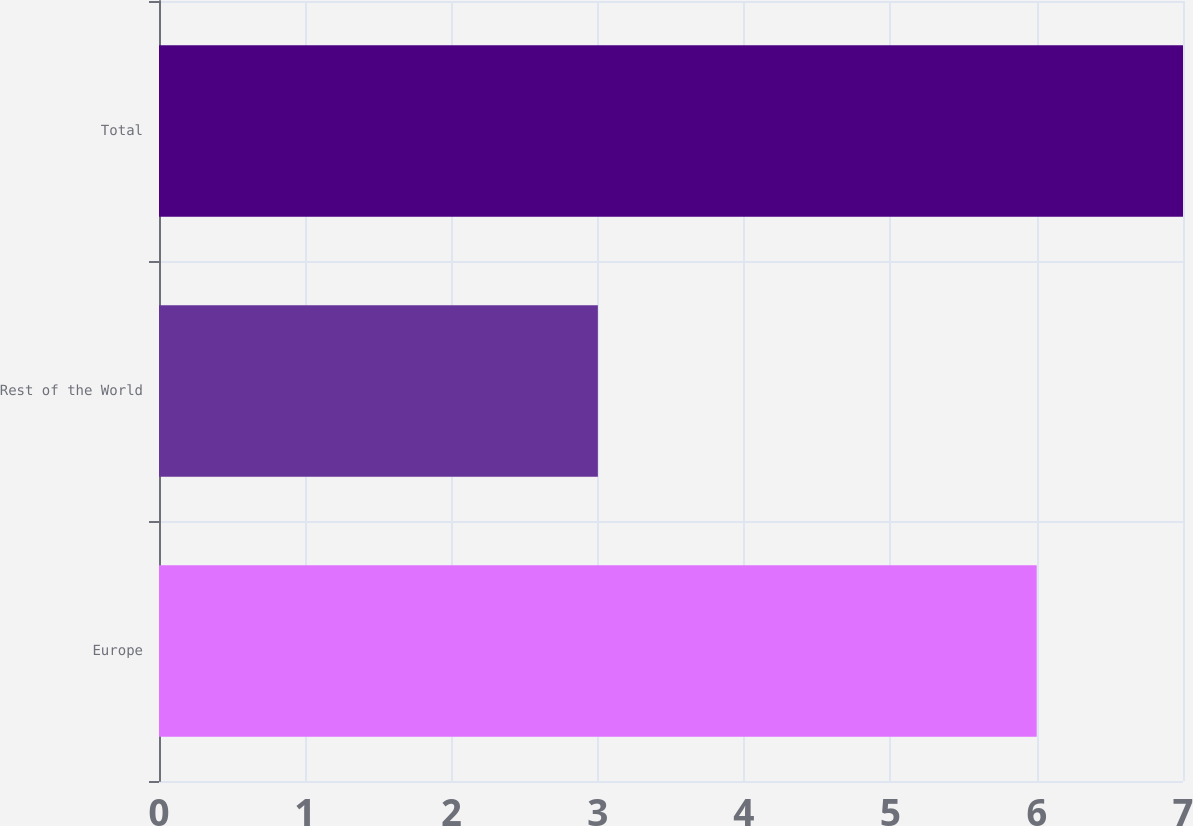Convert chart to OTSL. <chart><loc_0><loc_0><loc_500><loc_500><bar_chart><fcel>Europe<fcel>Rest of the World<fcel>Total<nl><fcel>6<fcel>3<fcel>7<nl></chart> 